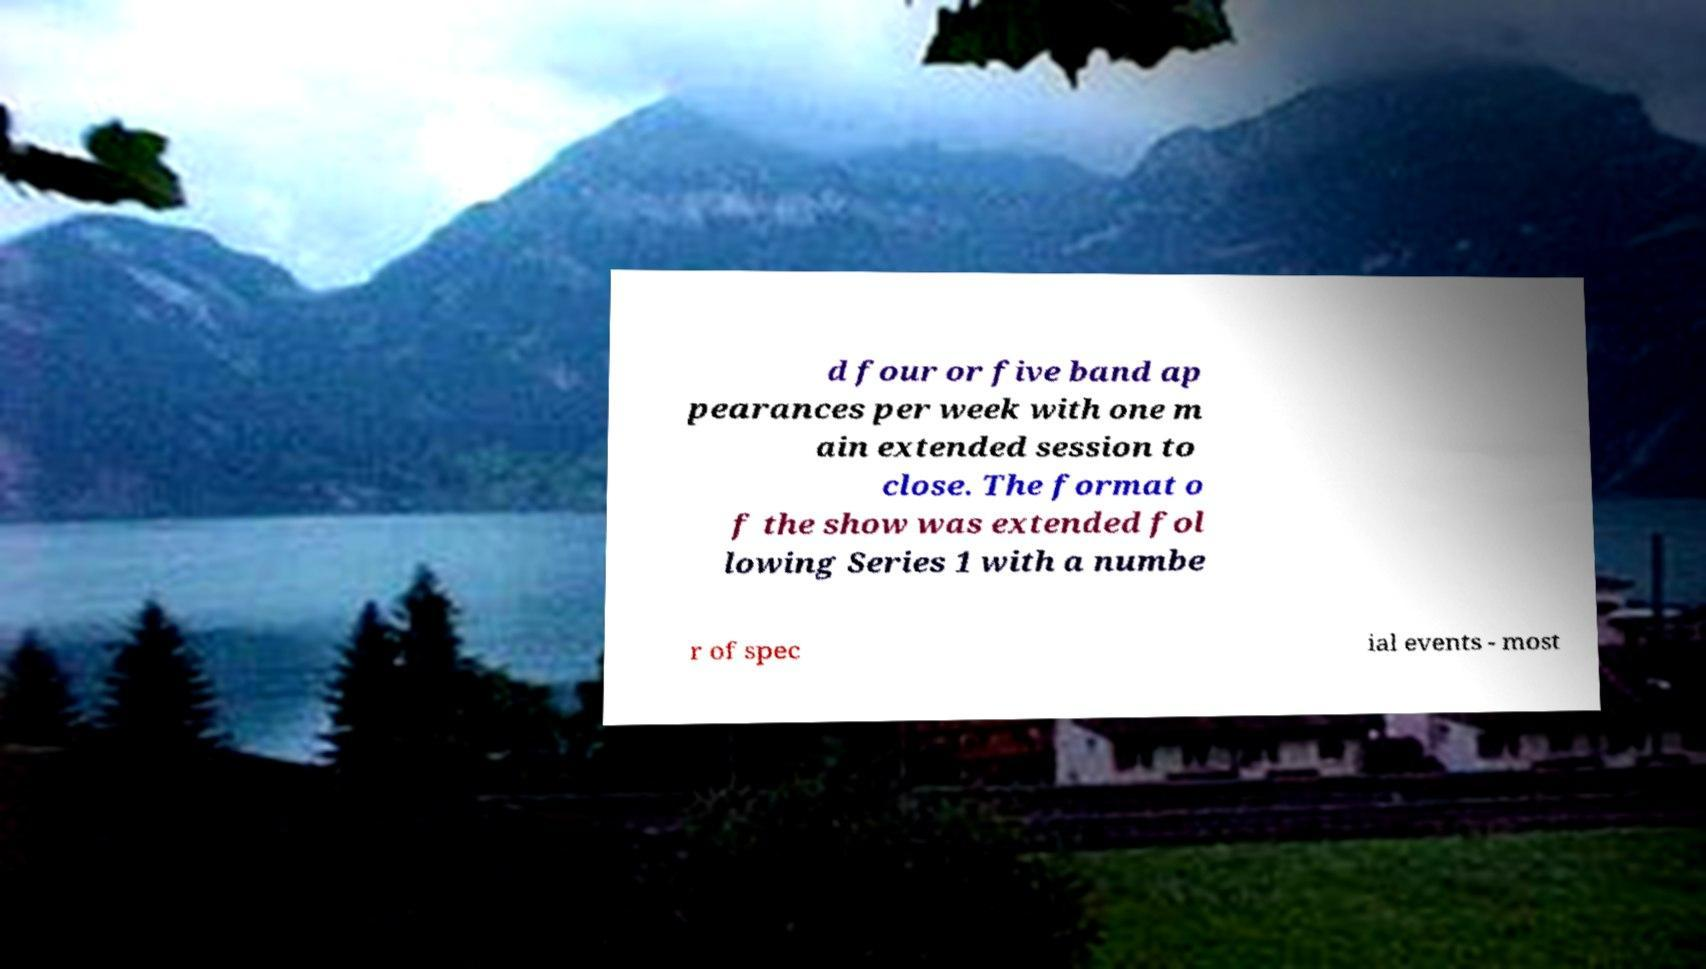Can you accurately transcribe the text from the provided image for me? d four or five band ap pearances per week with one m ain extended session to close. The format o f the show was extended fol lowing Series 1 with a numbe r of spec ial events - most 